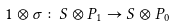<formula> <loc_0><loc_0><loc_500><loc_500>1 \otimes \sigma \colon S \otimes P _ { 1 } \rightarrow S \otimes P _ { 0 }</formula> 